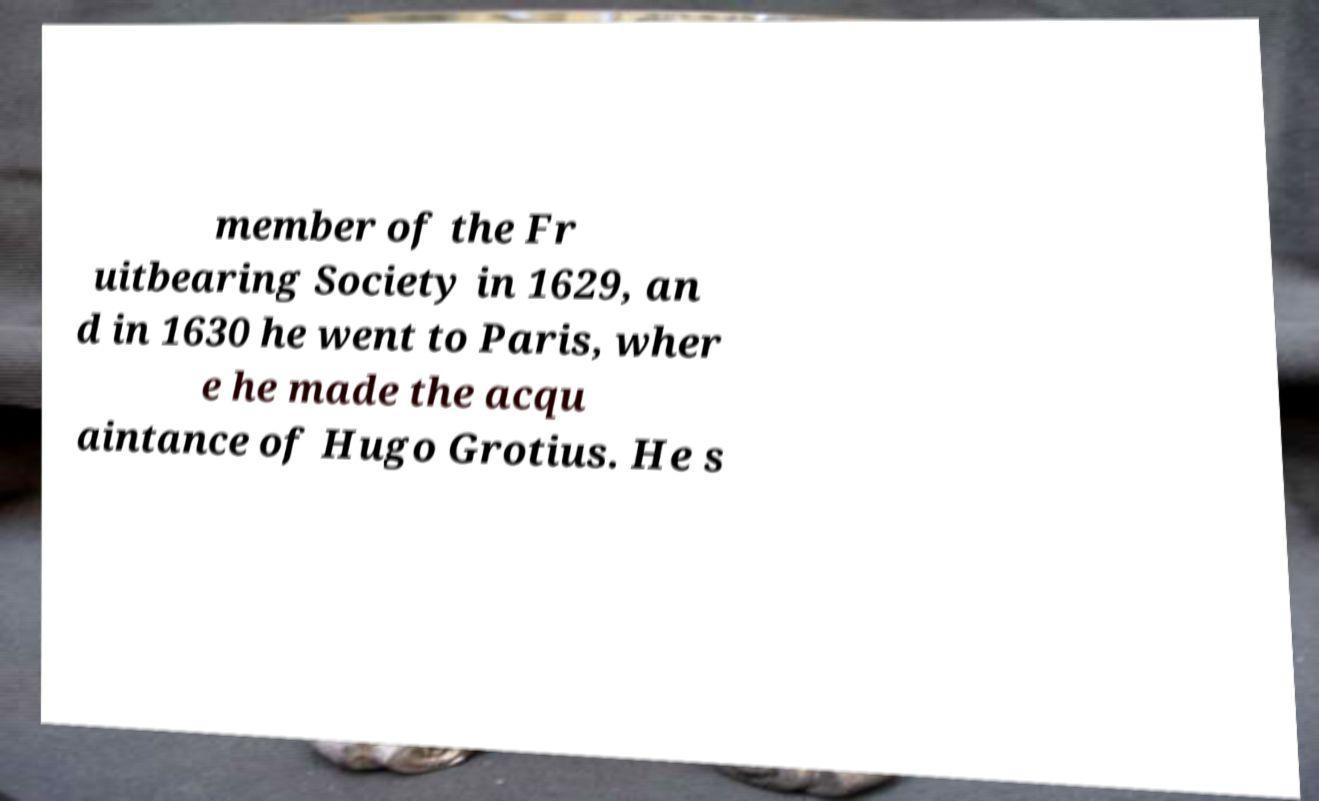Can you read and provide the text displayed in the image?This photo seems to have some interesting text. Can you extract and type it out for me? member of the Fr uitbearing Society in 1629, an d in 1630 he went to Paris, wher e he made the acqu aintance of Hugo Grotius. He s 